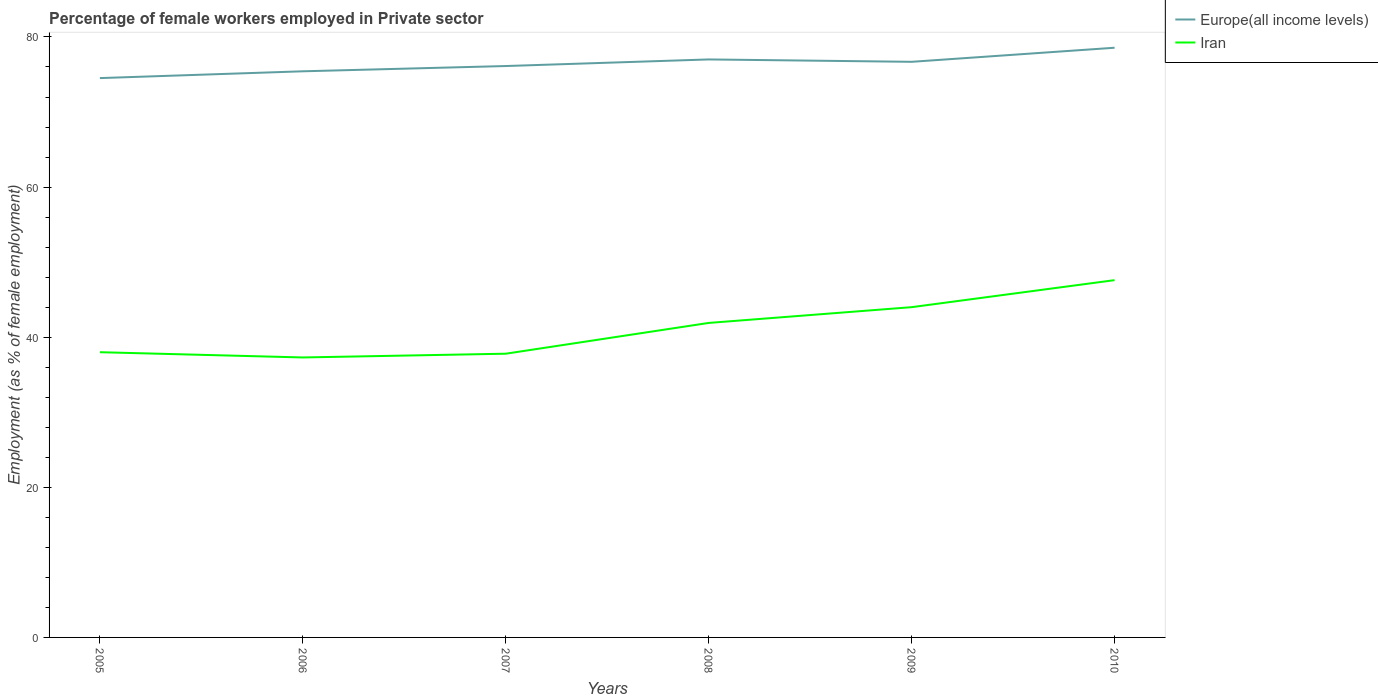Does the line corresponding to Iran intersect with the line corresponding to Europe(all income levels)?
Keep it short and to the point. No. Across all years, what is the maximum percentage of females employed in Private sector in Iran?
Your response must be concise. 37.3. In which year was the percentage of females employed in Private sector in Iran maximum?
Make the answer very short. 2006. What is the total percentage of females employed in Private sector in Iran in the graph?
Your answer should be compact. -4.6. What is the difference between the highest and the second highest percentage of females employed in Private sector in Europe(all income levels)?
Ensure brevity in your answer.  4.04. How many years are there in the graph?
Your answer should be compact. 6. Are the values on the major ticks of Y-axis written in scientific E-notation?
Make the answer very short. No. How are the legend labels stacked?
Provide a succinct answer. Vertical. What is the title of the graph?
Your answer should be compact. Percentage of female workers employed in Private sector. What is the label or title of the Y-axis?
Offer a terse response. Employment (as % of female employment). What is the Employment (as % of female employment) of Europe(all income levels) in 2005?
Your answer should be compact. 74.52. What is the Employment (as % of female employment) in Europe(all income levels) in 2006?
Your response must be concise. 75.42. What is the Employment (as % of female employment) in Iran in 2006?
Your answer should be compact. 37.3. What is the Employment (as % of female employment) in Europe(all income levels) in 2007?
Give a very brief answer. 76.13. What is the Employment (as % of female employment) in Iran in 2007?
Provide a short and direct response. 37.8. What is the Employment (as % of female employment) of Europe(all income levels) in 2008?
Your answer should be compact. 77. What is the Employment (as % of female employment) of Iran in 2008?
Offer a very short reply. 41.9. What is the Employment (as % of female employment) of Europe(all income levels) in 2009?
Your response must be concise. 76.69. What is the Employment (as % of female employment) in Europe(all income levels) in 2010?
Make the answer very short. 78.56. What is the Employment (as % of female employment) of Iran in 2010?
Ensure brevity in your answer.  47.6. Across all years, what is the maximum Employment (as % of female employment) in Europe(all income levels)?
Keep it short and to the point. 78.56. Across all years, what is the maximum Employment (as % of female employment) in Iran?
Your response must be concise. 47.6. Across all years, what is the minimum Employment (as % of female employment) in Europe(all income levels)?
Provide a short and direct response. 74.52. Across all years, what is the minimum Employment (as % of female employment) of Iran?
Offer a terse response. 37.3. What is the total Employment (as % of female employment) of Europe(all income levels) in the graph?
Provide a succinct answer. 458.33. What is the total Employment (as % of female employment) in Iran in the graph?
Ensure brevity in your answer.  246.6. What is the difference between the Employment (as % of female employment) in Europe(all income levels) in 2005 and that in 2006?
Provide a short and direct response. -0.9. What is the difference between the Employment (as % of female employment) of Europe(all income levels) in 2005 and that in 2007?
Provide a short and direct response. -1.61. What is the difference between the Employment (as % of female employment) of Europe(all income levels) in 2005 and that in 2008?
Keep it short and to the point. -2.49. What is the difference between the Employment (as % of female employment) in Europe(all income levels) in 2005 and that in 2009?
Ensure brevity in your answer.  -2.17. What is the difference between the Employment (as % of female employment) in Europe(all income levels) in 2005 and that in 2010?
Make the answer very short. -4.04. What is the difference between the Employment (as % of female employment) of Europe(all income levels) in 2006 and that in 2007?
Ensure brevity in your answer.  -0.7. What is the difference between the Employment (as % of female employment) in Europe(all income levels) in 2006 and that in 2008?
Provide a succinct answer. -1.58. What is the difference between the Employment (as % of female employment) of Iran in 2006 and that in 2008?
Provide a succinct answer. -4.6. What is the difference between the Employment (as % of female employment) in Europe(all income levels) in 2006 and that in 2009?
Offer a very short reply. -1.26. What is the difference between the Employment (as % of female employment) in Europe(all income levels) in 2006 and that in 2010?
Provide a short and direct response. -3.14. What is the difference between the Employment (as % of female employment) of Iran in 2006 and that in 2010?
Make the answer very short. -10.3. What is the difference between the Employment (as % of female employment) in Europe(all income levels) in 2007 and that in 2008?
Your response must be concise. -0.88. What is the difference between the Employment (as % of female employment) in Iran in 2007 and that in 2008?
Ensure brevity in your answer.  -4.1. What is the difference between the Employment (as % of female employment) of Europe(all income levels) in 2007 and that in 2009?
Offer a terse response. -0.56. What is the difference between the Employment (as % of female employment) in Iran in 2007 and that in 2009?
Make the answer very short. -6.2. What is the difference between the Employment (as % of female employment) of Europe(all income levels) in 2007 and that in 2010?
Keep it short and to the point. -2.44. What is the difference between the Employment (as % of female employment) of Iran in 2007 and that in 2010?
Make the answer very short. -9.8. What is the difference between the Employment (as % of female employment) of Europe(all income levels) in 2008 and that in 2009?
Offer a terse response. 0.32. What is the difference between the Employment (as % of female employment) in Iran in 2008 and that in 2009?
Provide a short and direct response. -2.1. What is the difference between the Employment (as % of female employment) in Europe(all income levels) in 2008 and that in 2010?
Offer a very short reply. -1.56. What is the difference between the Employment (as % of female employment) in Iran in 2008 and that in 2010?
Offer a terse response. -5.7. What is the difference between the Employment (as % of female employment) of Europe(all income levels) in 2009 and that in 2010?
Give a very brief answer. -1.88. What is the difference between the Employment (as % of female employment) in Europe(all income levels) in 2005 and the Employment (as % of female employment) in Iran in 2006?
Your response must be concise. 37.22. What is the difference between the Employment (as % of female employment) in Europe(all income levels) in 2005 and the Employment (as % of female employment) in Iran in 2007?
Give a very brief answer. 36.72. What is the difference between the Employment (as % of female employment) in Europe(all income levels) in 2005 and the Employment (as % of female employment) in Iran in 2008?
Your answer should be compact. 32.62. What is the difference between the Employment (as % of female employment) in Europe(all income levels) in 2005 and the Employment (as % of female employment) in Iran in 2009?
Make the answer very short. 30.52. What is the difference between the Employment (as % of female employment) in Europe(all income levels) in 2005 and the Employment (as % of female employment) in Iran in 2010?
Your response must be concise. 26.92. What is the difference between the Employment (as % of female employment) in Europe(all income levels) in 2006 and the Employment (as % of female employment) in Iran in 2007?
Your answer should be compact. 37.62. What is the difference between the Employment (as % of female employment) of Europe(all income levels) in 2006 and the Employment (as % of female employment) of Iran in 2008?
Give a very brief answer. 33.52. What is the difference between the Employment (as % of female employment) in Europe(all income levels) in 2006 and the Employment (as % of female employment) in Iran in 2009?
Keep it short and to the point. 31.42. What is the difference between the Employment (as % of female employment) in Europe(all income levels) in 2006 and the Employment (as % of female employment) in Iran in 2010?
Provide a short and direct response. 27.82. What is the difference between the Employment (as % of female employment) of Europe(all income levels) in 2007 and the Employment (as % of female employment) of Iran in 2008?
Your response must be concise. 34.23. What is the difference between the Employment (as % of female employment) in Europe(all income levels) in 2007 and the Employment (as % of female employment) in Iran in 2009?
Your answer should be very brief. 32.13. What is the difference between the Employment (as % of female employment) of Europe(all income levels) in 2007 and the Employment (as % of female employment) of Iran in 2010?
Your answer should be very brief. 28.53. What is the difference between the Employment (as % of female employment) of Europe(all income levels) in 2008 and the Employment (as % of female employment) of Iran in 2009?
Make the answer very short. 33.01. What is the difference between the Employment (as % of female employment) of Europe(all income levels) in 2008 and the Employment (as % of female employment) of Iran in 2010?
Ensure brevity in your answer.  29.41. What is the difference between the Employment (as % of female employment) in Europe(all income levels) in 2009 and the Employment (as % of female employment) in Iran in 2010?
Provide a short and direct response. 29.09. What is the average Employment (as % of female employment) of Europe(all income levels) per year?
Your answer should be very brief. 76.39. What is the average Employment (as % of female employment) of Iran per year?
Make the answer very short. 41.1. In the year 2005, what is the difference between the Employment (as % of female employment) in Europe(all income levels) and Employment (as % of female employment) in Iran?
Your response must be concise. 36.52. In the year 2006, what is the difference between the Employment (as % of female employment) in Europe(all income levels) and Employment (as % of female employment) in Iran?
Offer a very short reply. 38.12. In the year 2007, what is the difference between the Employment (as % of female employment) of Europe(all income levels) and Employment (as % of female employment) of Iran?
Keep it short and to the point. 38.33. In the year 2008, what is the difference between the Employment (as % of female employment) in Europe(all income levels) and Employment (as % of female employment) in Iran?
Give a very brief answer. 35.1. In the year 2009, what is the difference between the Employment (as % of female employment) of Europe(all income levels) and Employment (as % of female employment) of Iran?
Ensure brevity in your answer.  32.69. In the year 2010, what is the difference between the Employment (as % of female employment) of Europe(all income levels) and Employment (as % of female employment) of Iran?
Your answer should be compact. 30.96. What is the ratio of the Employment (as % of female employment) in Iran in 2005 to that in 2006?
Ensure brevity in your answer.  1.02. What is the ratio of the Employment (as % of female employment) of Europe(all income levels) in 2005 to that in 2007?
Your answer should be compact. 0.98. What is the ratio of the Employment (as % of female employment) in Iran in 2005 to that in 2007?
Your answer should be very brief. 1.01. What is the ratio of the Employment (as % of female employment) of Iran in 2005 to that in 2008?
Your response must be concise. 0.91. What is the ratio of the Employment (as % of female employment) of Europe(all income levels) in 2005 to that in 2009?
Keep it short and to the point. 0.97. What is the ratio of the Employment (as % of female employment) in Iran in 2005 to that in 2009?
Offer a terse response. 0.86. What is the ratio of the Employment (as % of female employment) in Europe(all income levels) in 2005 to that in 2010?
Your answer should be very brief. 0.95. What is the ratio of the Employment (as % of female employment) of Iran in 2005 to that in 2010?
Provide a short and direct response. 0.8. What is the ratio of the Employment (as % of female employment) of Europe(all income levels) in 2006 to that in 2007?
Offer a very short reply. 0.99. What is the ratio of the Employment (as % of female employment) of Iran in 2006 to that in 2007?
Your answer should be compact. 0.99. What is the ratio of the Employment (as % of female employment) in Europe(all income levels) in 2006 to that in 2008?
Your answer should be very brief. 0.98. What is the ratio of the Employment (as % of female employment) in Iran in 2006 to that in 2008?
Make the answer very short. 0.89. What is the ratio of the Employment (as % of female employment) of Europe(all income levels) in 2006 to that in 2009?
Make the answer very short. 0.98. What is the ratio of the Employment (as % of female employment) of Iran in 2006 to that in 2009?
Provide a short and direct response. 0.85. What is the ratio of the Employment (as % of female employment) in Europe(all income levels) in 2006 to that in 2010?
Make the answer very short. 0.96. What is the ratio of the Employment (as % of female employment) in Iran in 2006 to that in 2010?
Offer a very short reply. 0.78. What is the ratio of the Employment (as % of female employment) in Europe(all income levels) in 2007 to that in 2008?
Keep it short and to the point. 0.99. What is the ratio of the Employment (as % of female employment) in Iran in 2007 to that in 2008?
Your answer should be very brief. 0.9. What is the ratio of the Employment (as % of female employment) in Europe(all income levels) in 2007 to that in 2009?
Provide a succinct answer. 0.99. What is the ratio of the Employment (as % of female employment) of Iran in 2007 to that in 2009?
Ensure brevity in your answer.  0.86. What is the ratio of the Employment (as % of female employment) in Europe(all income levels) in 2007 to that in 2010?
Provide a succinct answer. 0.97. What is the ratio of the Employment (as % of female employment) of Iran in 2007 to that in 2010?
Ensure brevity in your answer.  0.79. What is the ratio of the Employment (as % of female employment) of Iran in 2008 to that in 2009?
Your response must be concise. 0.95. What is the ratio of the Employment (as % of female employment) in Europe(all income levels) in 2008 to that in 2010?
Provide a succinct answer. 0.98. What is the ratio of the Employment (as % of female employment) in Iran in 2008 to that in 2010?
Provide a succinct answer. 0.88. What is the ratio of the Employment (as % of female employment) in Europe(all income levels) in 2009 to that in 2010?
Make the answer very short. 0.98. What is the ratio of the Employment (as % of female employment) of Iran in 2009 to that in 2010?
Offer a very short reply. 0.92. What is the difference between the highest and the second highest Employment (as % of female employment) of Europe(all income levels)?
Provide a short and direct response. 1.56. What is the difference between the highest and the lowest Employment (as % of female employment) of Europe(all income levels)?
Provide a succinct answer. 4.04. What is the difference between the highest and the lowest Employment (as % of female employment) of Iran?
Your answer should be compact. 10.3. 